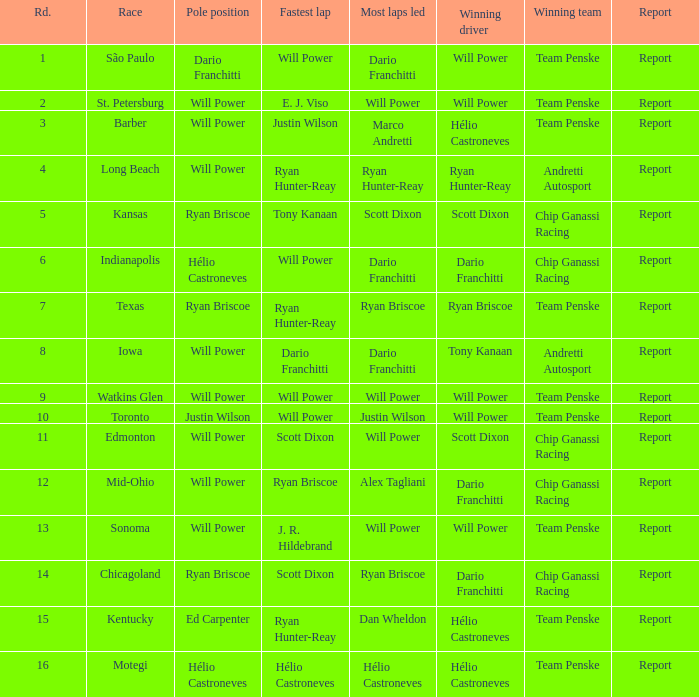Who was on the pole at Chicagoland? Ryan Briscoe. 